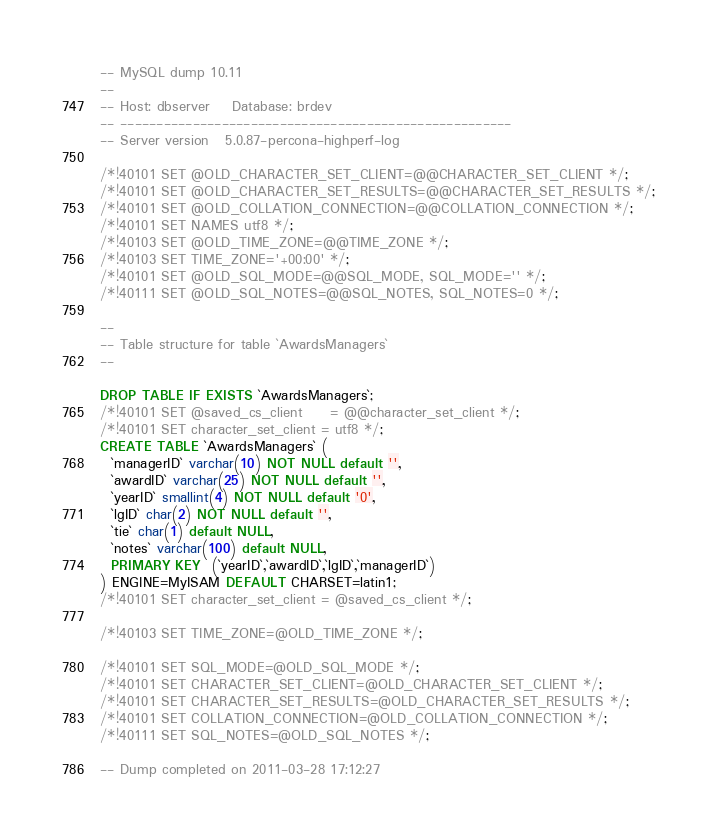Convert code to text. <code><loc_0><loc_0><loc_500><loc_500><_SQL_>-- MySQL dump 10.11
--
-- Host: dbserver    Database: brdev
-- ------------------------------------------------------
-- Server version	5.0.87-percona-highperf-log

/*!40101 SET @OLD_CHARACTER_SET_CLIENT=@@CHARACTER_SET_CLIENT */;
/*!40101 SET @OLD_CHARACTER_SET_RESULTS=@@CHARACTER_SET_RESULTS */;
/*!40101 SET @OLD_COLLATION_CONNECTION=@@COLLATION_CONNECTION */;
/*!40101 SET NAMES utf8 */;
/*!40103 SET @OLD_TIME_ZONE=@@TIME_ZONE */;
/*!40103 SET TIME_ZONE='+00:00' */;
/*!40101 SET @OLD_SQL_MODE=@@SQL_MODE, SQL_MODE='' */;
/*!40111 SET @OLD_SQL_NOTES=@@SQL_NOTES, SQL_NOTES=0 */;

--
-- Table structure for table `AwardsManagers`
--

DROP TABLE IF EXISTS `AwardsManagers`;
/*!40101 SET @saved_cs_client     = @@character_set_client */;
/*!40101 SET character_set_client = utf8 */;
CREATE TABLE `AwardsManagers` (
  `managerID` varchar(10) NOT NULL default '',
  `awardID` varchar(25) NOT NULL default '',
  `yearID` smallint(4) NOT NULL default '0',
  `lgID` char(2) NOT NULL default '',
  `tie` char(1) default NULL,
  `notes` varchar(100) default NULL,
  PRIMARY KEY  (`yearID`,`awardID`,`lgID`,`managerID`)
) ENGINE=MyISAM DEFAULT CHARSET=latin1;
/*!40101 SET character_set_client = @saved_cs_client */;

/*!40103 SET TIME_ZONE=@OLD_TIME_ZONE */;

/*!40101 SET SQL_MODE=@OLD_SQL_MODE */;
/*!40101 SET CHARACTER_SET_CLIENT=@OLD_CHARACTER_SET_CLIENT */;
/*!40101 SET CHARACTER_SET_RESULTS=@OLD_CHARACTER_SET_RESULTS */;
/*!40101 SET COLLATION_CONNECTION=@OLD_COLLATION_CONNECTION */;
/*!40111 SET SQL_NOTES=@OLD_SQL_NOTES */;

-- Dump completed on 2011-03-28 17:12:27
</code> 